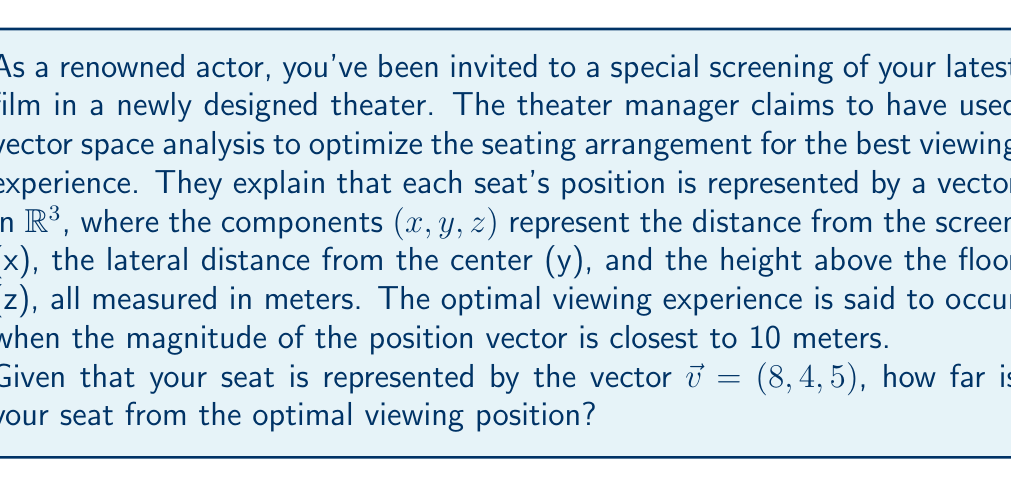Provide a solution to this math problem. To solve this problem, we'll use concepts from vector spaces and calculate the difference between the magnitude of your seat's position vector and the optimal viewing distance.

Step 1: Calculate the magnitude of your seat's position vector.
The magnitude of a vector $\vec{v} = (x, y, z)$ is given by:
$$\|\vec{v}\| = \sqrt{x^2 + y^2 + z^2}$$

For your seat: $\vec{v} = (8, 4, 5)$
$$\|\vec{v}\| = \sqrt{8^2 + 4^2 + 5^2} = \sqrt{64 + 16 + 25} = \sqrt{105}$$

Step 2: Calculate the difference between your seat's position magnitude and the optimal viewing distance.
The optimal viewing distance is 10 meters, so we need to find:
$$|\|\vec{v}\| - 10|$$

Step 3: Simplify the expression.
$$|\sqrt{105} - 10|$$

Step 4: Calculate the final result.
$$\sqrt{105} \approx 10.247$$
$$|10.247 - 10| \approx 0.247$$

Therefore, your seat is approximately 0.247 meters (or 24.7 cm) away from the optimal viewing position.
Answer: The seat is approximately 0.247 meters (or 24.7 cm) away from the optimal viewing position. 